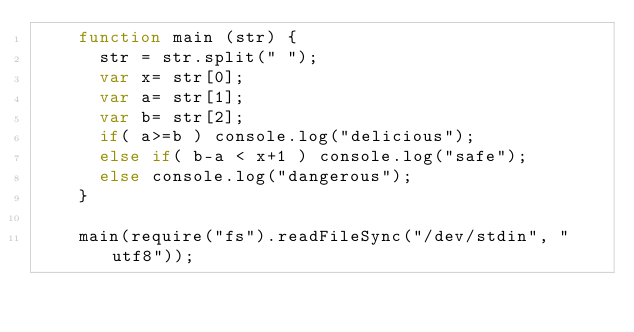<code> <loc_0><loc_0><loc_500><loc_500><_JavaScript_>    function main (str) {
      str = str.split(" ");
      var x= str[0];
      var a= str[1];
      var b= str[2];
      if( a>=b ) console.log("delicious");
      else if( b-a < x+1 ) console.log("safe");
      else console.log("dangerous");
    }

    main(require("fs").readFileSync("/dev/stdin", "utf8"));</code> 